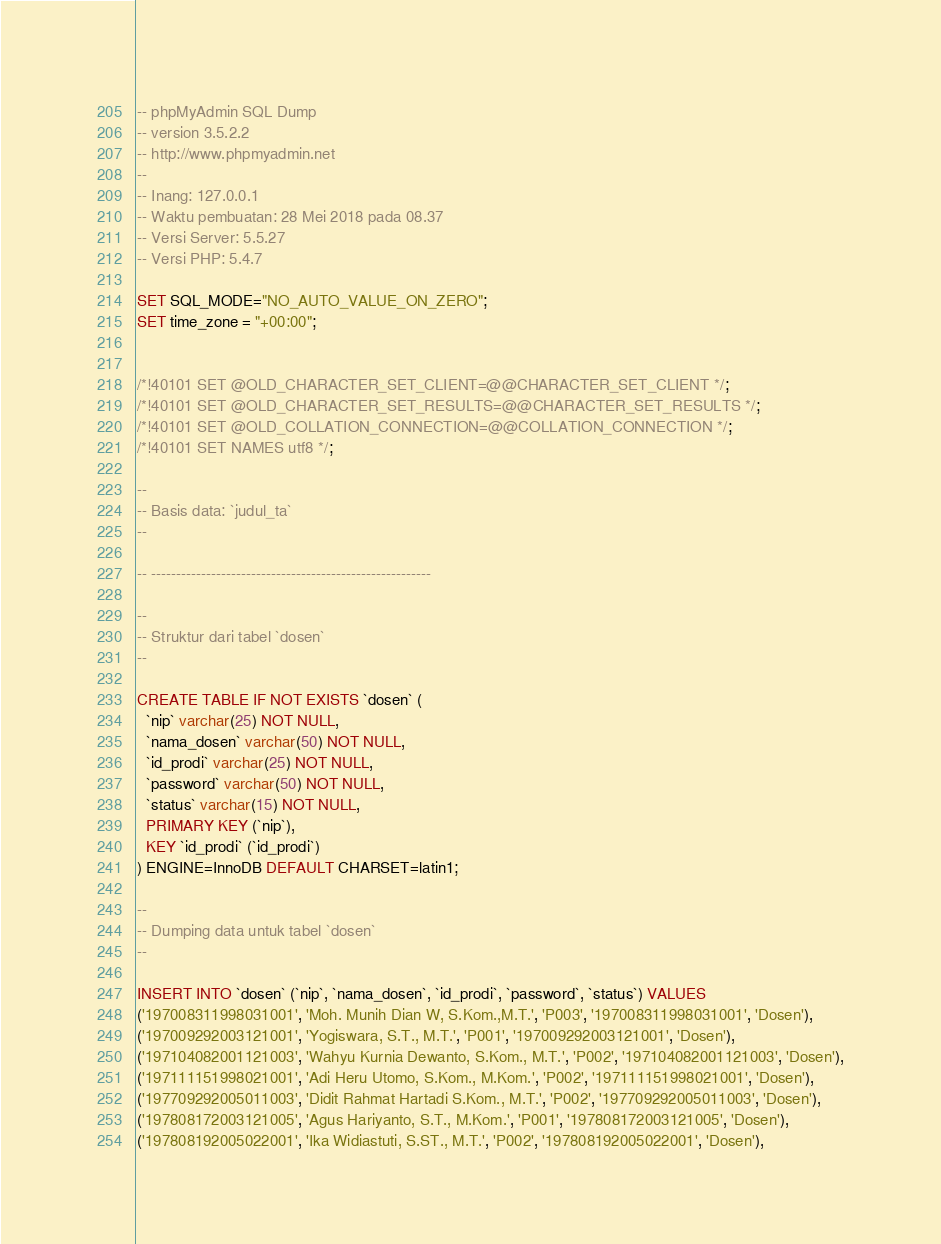Convert code to text. <code><loc_0><loc_0><loc_500><loc_500><_SQL_>-- phpMyAdmin SQL Dump
-- version 3.5.2.2
-- http://www.phpmyadmin.net
--
-- Inang: 127.0.0.1
-- Waktu pembuatan: 28 Mei 2018 pada 08.37
-- Versi Server: 5.5.27
-- Versi PHP: 5.4.7

SET SQL_MODE="NO_AUTO_VALUE_ON_ZERO";
SET time_zone = "+00:00";


/*!40101 SET @OLD_CHARACTER_SET_CLIENT=@@CHARACTER_SET_CLIENT */;
/*!40101 SET @OLD_CHARACTER_SET_RESULTS=@@CHARACTER_SET_RESULTS */;
/*!40101 SET @OLD_COLLATION_CONNECTION=@@COLLATION_CONNECTION */;
/*!40101 SET NAMES utf8 */;

--
-- Basis data: `judul_ta`
--

-- --------------------------------------------------------

--
-- Struktur dari tabel `dosen`
--

CREATE TABLE IF NOT EXISTS `dosen` (
  `nip` varchar(25) NOT NULL,
  `nama_dosen` varchar(50) NOT NULL,
  `id_prodi` varchar(25) NOT NULL,
  `password` varchar(50) NOT NULL,
  `status` varchar(15) NOT NULL,
  PRIMARY KEY (`nip`),
  KEY `id_prodi` (`id_prodi`)
) ENGINE=InnoDB DEFAULT CHARSET=latin1;

--
-- Dumping data untuk tabel `dosen`
--

INSERT INTO `dosen` (`nip`, `nama_dosen`, `id_prodi`, `password`, `status`) VALUES
('197008311998031001', 'Moh. Munih Dian W, S.Kom.,M.T.', 'P003', '197008311998031001', 'Dosen'),
('197009292003121001', 'Yogiswara, S.T., M.T.', 'P001', '197009292003121001', 'Dosen'),
('197104082001121003', 'Wahyu Kurnia Dewanto, S.Kom., M.T.', 'P002', '197104082001121003', 'Dosen'),
('197111151998021001', 'Adi Heru Utomo, S.Kom., M.Kom.', 'P002', '197111151998021001', 'Dosen'),
('197709292005011003', 'Didit Rahmat Hartadi S.Kom., M.T.', 'P002', '197709292005011003', 'Dosen'),
('197808172003121005', 'Agus Hariyanto, S.T., M.Kom.', 'P001', '197808172003121005', 'Dosen'),
('197808192005022001', 'Ika Widiastuti, S.ST., M.T.', 'P002', '197808192005022001', 'Dosen'),</code> 